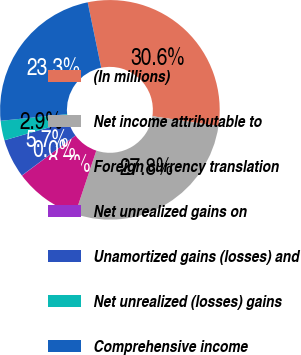<chart> <loc_0><loc_0><loc_500><loc_500><pie_chart><fcel>(In millions)<fcel>Net income attributable to<fcel>Foreign currency translation<fcel>Net unrealized gains on<fcel>Unamortized gains (losses) and<fcel>Net unrealized (losses) gains<fcel>Comprehensive income<nl><fcel>30.61%<fcel>27.76%<fcel>9.66%<fcel>0.03%<fcel>5.72%<fcel>2.88%<fcel>23.35%<nl></chart> 